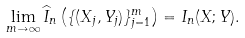Convert formula to latex. <formula><loc_0><loc_0><loc_500><loc_500>\lim _ { m \to \infty } \widehat { I } _ { n } \left ( \{ ( X _ { j } , Y _ { j } ) \} _ { j = 1 } ^ { m } \right ) = I _ { n } ( X ; Y ) .</formula> 